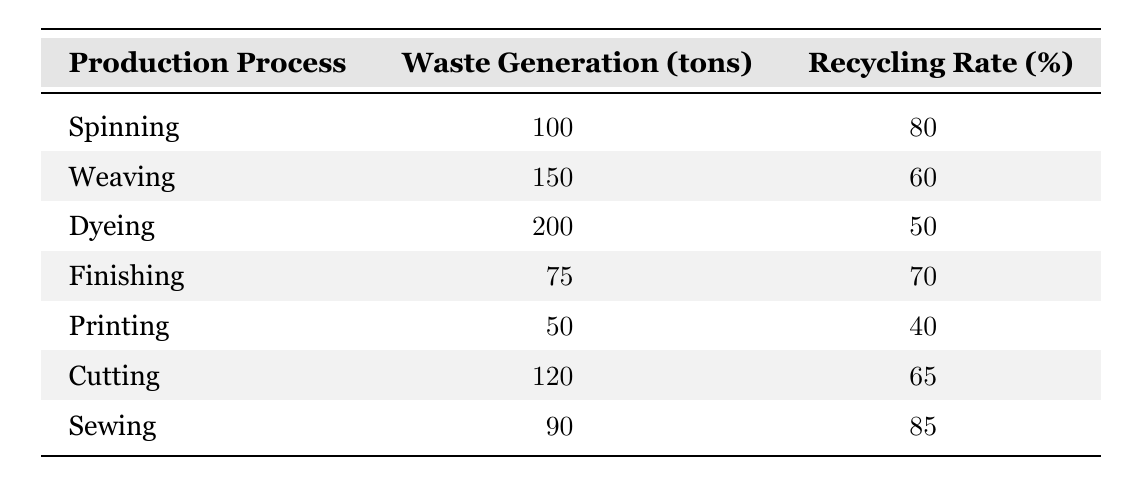What is the recycling rate for the dyeing process? The table lists the recycling rate for the dyeing process as 50 percent.
Answer: 50 How much waste is generated during the weaving process? According to the table, the waste generation for the weaving process is 150 tons.
Answer: 150 Which production process has the highest recycling rate? The sewing process has the highest recycling rate at 85 percent, which is greater than all other rates in the table.
Answer: 85 What is the total waste generation across all production processes? To find the total waste generation, sum up the waste for all processes: 100 + 150 + 200 + 75 + 50 + 120 + 90 = 785 tons.
Answer: 785 Is the recycling rate for cutting higher than that for printing? Yes, the cutting process has a recycling rate of 65 percent, while printing has a recycling rate of 40 percent, so cutting is higher.
Answer: Yes What is the average waste generation for the processes listed? To find the average, first sum the waste generation: 100 + 150 + 200 + 75 + 50 + 120 + 90 = 785 tons. There are 7 processes, so the average is 785 / 7 = 112.14 tons.
Answer: 112.14 Do any of the production processes generate less waste than finishing? Yes, the printing process generates 50 tons, which is less than the 75 tons generated in finishing.
Answer: Yes What is the difference in waste generation between the dyeing and spinning processes? The dyeing process generates 200 tons, while spinning generates 100 tons. The difference is 200 - 100 = 100 tons.
Answer: 100 Which two processes have the lowest recycling rates? The printing and dyeing processes have the lowest recycling rates at 40 percent and 50 percent, respectively.
Answer: Printing and Dyeing 